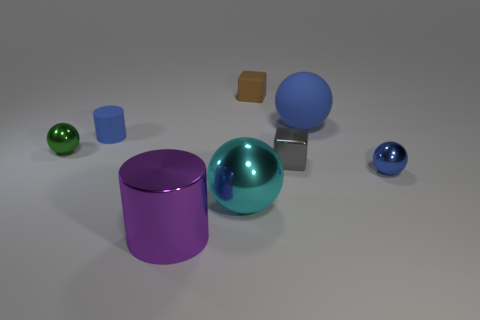Subtract all purple cylinders. How many blue spheres are left? 2 Subtract all green spheres. How many spheres are left? 3 Subtract all large metal spheres. How many spheres are left? 3 Subtract 1 balls. How many balls are left? 3 Add 2 green matte things. How many objects exist? 10 Subtract all purple balls. Subtract all yellow cylinders. How many balls are left? 4 Subtract all cylinders. How many objects are left? 6 Subtract 0 gray cylinders. How many objects are left? 8 Subtract all large cyan things. Subtract all purple things. How many objects are left? 6 Add 7 blue shiny spheres. How many blue shiny spheres are left? 8 